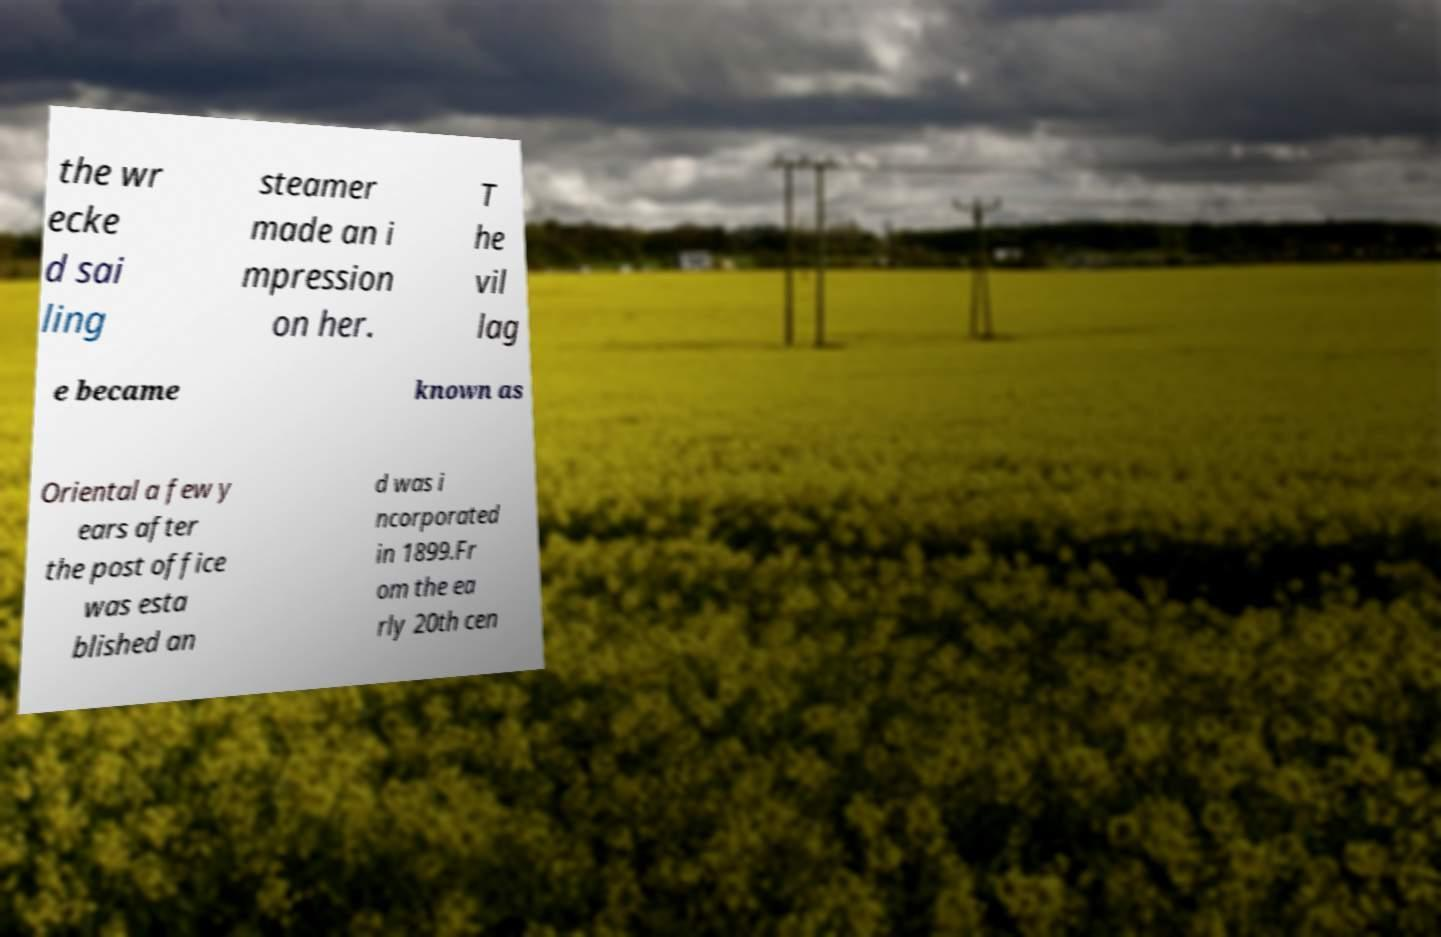I need the written content from this picture converted into text. Can you do that? the wr ecke d sai ling steamer made an i mpression on her. T he vil lag e became known as Oriental a few y ears after the post office was esta blished an d was i ncorporated in 1899.Fr om the ea rly 20th cen 